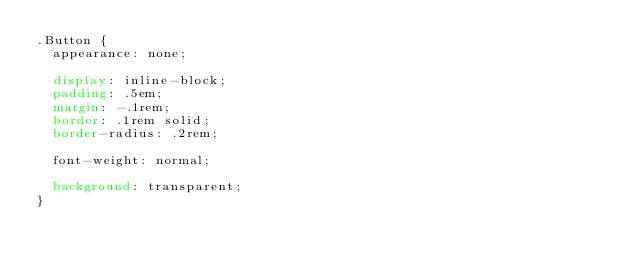<code> <loc_0><loc_0><loc_500><loc_500><_CSS_>.Button {
  appearance: none;

  display: inline-block;
  padding: .5em;
  margin: -.1rem;
  border: .1rem solid;
  border-radius: .2rem;

  font-weight: normal;

  background: transparent;
}
</code> 